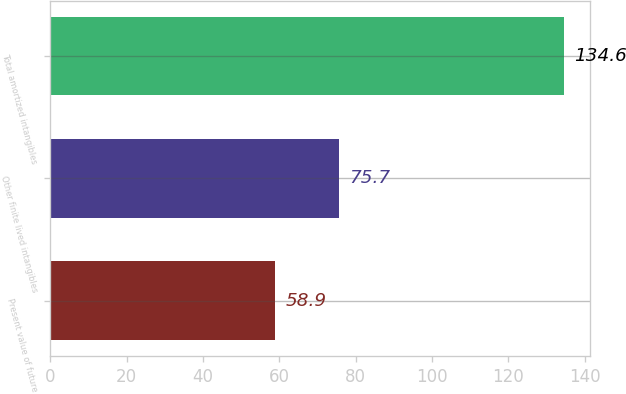<chart> <loc_0><loc_0><loc_500><loc_500><bar_chart><fcel>Present value of future<fcel>Other finite lived intangibles<fcel>Total amortized intangibles<nl><fcel>58.9<fcel>75.7<fcel>134.6<nl></chart> 